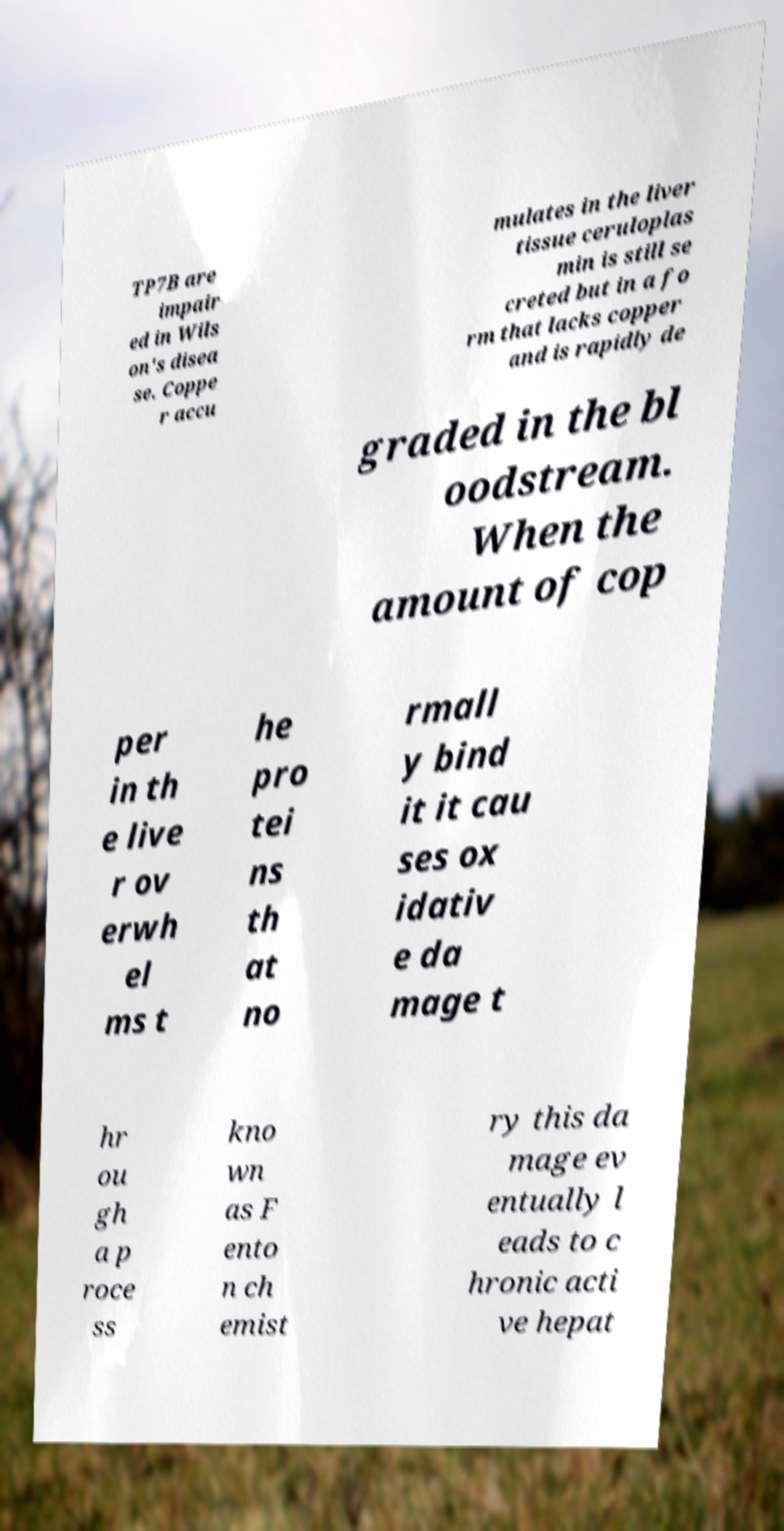Please identify and transcribe the text found in this image. TP7B are impair ed in Wils on's disea se. Coppe r accu mulates in the liver tissue ceruloplas min is still se creted but in a fo rm that lacks copper and is rapidly de graded in the bl oodstream. When the amount of cop per in th e live r ov erwh el ms t he pro tei ns th at no rmall y bind it it cau ses ox idativ e da mage t hr ou gh a p roce ss kno wn as F ento n ch emist ry this da mage ev entually l eads to c hronic acti ve hepat 